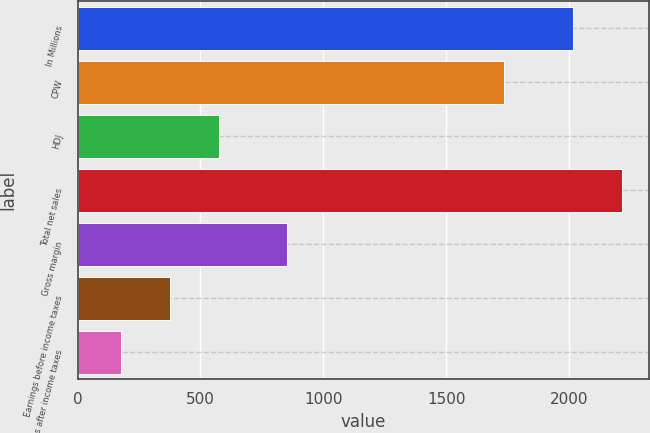Convert chart to OTSL. <chart><loc_0><loc_0><loc_500><loc_500><bar_chart><fcel>In Millions<fcel>CPW<fcel>HDJ<fcel>Total net sales<fcel>Gross margin<fcel>Earnings before income taxes<fcel>Earnings after income taxes<nl><fcel>2018<fcel>1734<fcel>574.24<fcel>2216.77<fcel>853.6<fcel>375.47<fcel>176.7<nl></chart> 